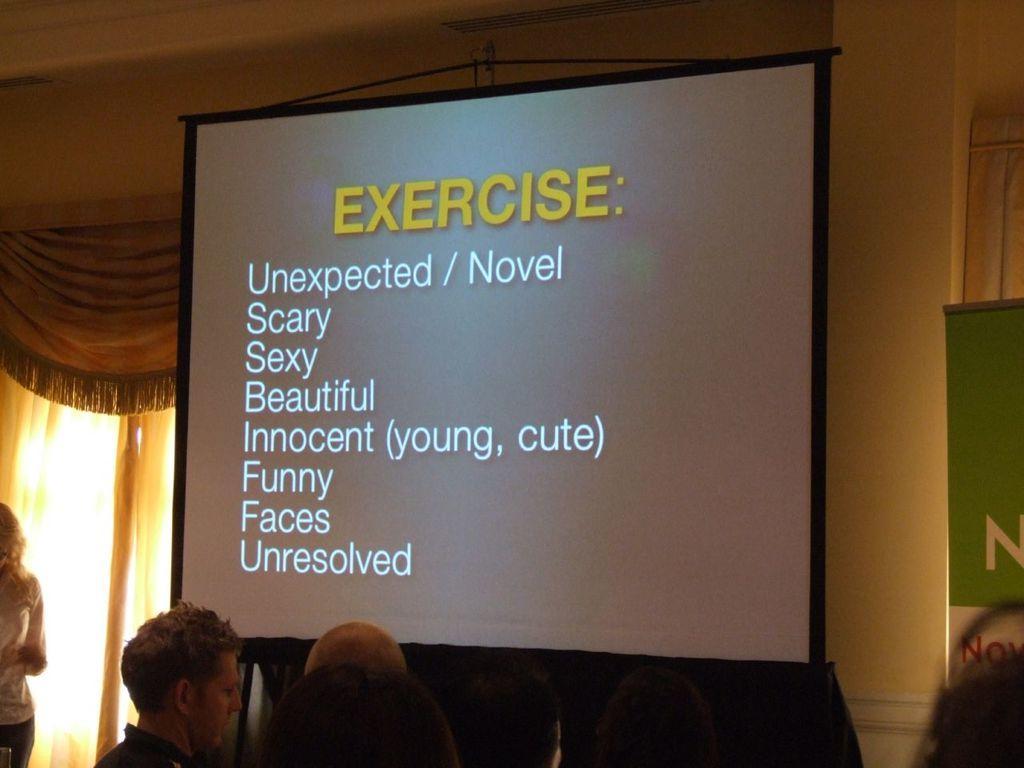In one or two sentences, can you explain what this image depicts? In this image we can see a projector with some text, there are few people and curtains, also we can see a board and the wall. 